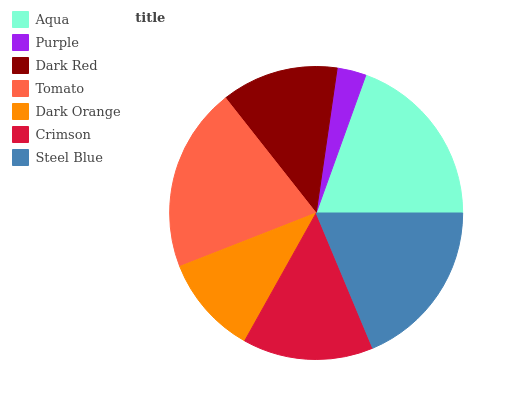Is Purple the minimum?
Answer yes or no. Yes. Is Tomato the maximum?
Answer yes or no. Yes. Is Dark Red the minimum?
Answer yes or no. No. Is Dark Red the maximum?
Answer yes or no. No. Is Dark Red greater than Purple?
Answer yes or no. Yes. Is Purple less than Dark Red?
Answer yes or no. Yes. Is Purple greater than Dark Red?
Answer yes or no. No. Is Dark Red less than Purple?
Answer yes or no. No. Is Crimson the high median?
Answer yes or no. Yes. Is Crimson the low median?
Answer yes or no. Yes. Is Dark Red the high median?
Answer yes or no. No. Is Purple the low median?
Answer yes or no. No. 